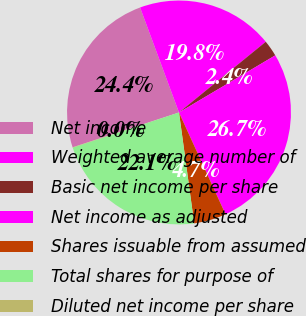Convert chart to OTSL. <chart><loc_0><loc_0><loc_500><loc_500><pie_chart><fcel>Net income<fcel>Weighted average number of<fcel>Basic net income per share<fcel>Net income as adjusted<fcel>Shares issuable from assumed<fcel>Total shares for purpose of<fcel>Diluted net income per share<nl><fcel>24.39%<fcel>19.77%<fcel>2.36%<fcel>26.7%<fcel>4.66%<fcel>22.08%<fcel>0.05%<nl></chart> 